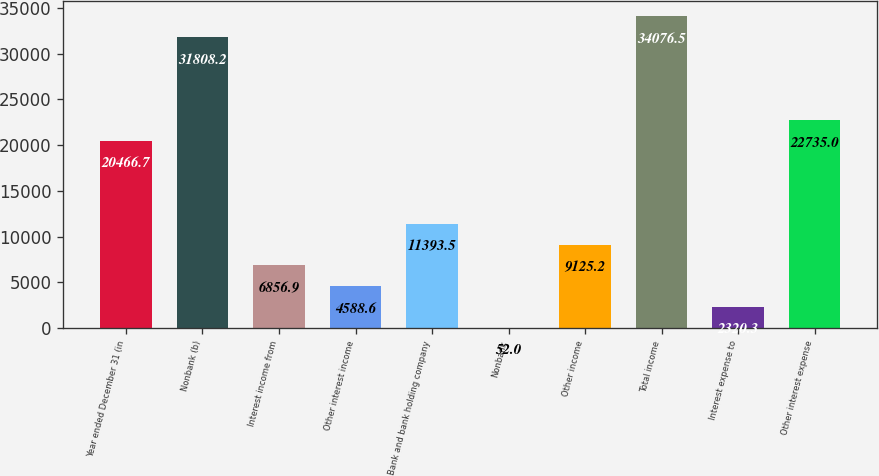<chart> <loc_0><loc_0><loc_500><loc_500><bar_chart><fcel>Year ended December 31 (in<fcel>Nonbank (b)<fcel>Interest income from<fcel>Other interest income<fcel>Bank and bank holding company<fcel>Nonbank<fcel>Other income<fcel>Total income<fcel>Interest expense to<fcel>Other interest expense<nl><fcel>20466.7<fcel>31808.2<fcel>6856.9<fcel>4588.6<fcel>11393.5<fcel>52<fcel>9125.2<fcel>34076.5<fcel>2320.3<fcel>22735<nl></chart> 